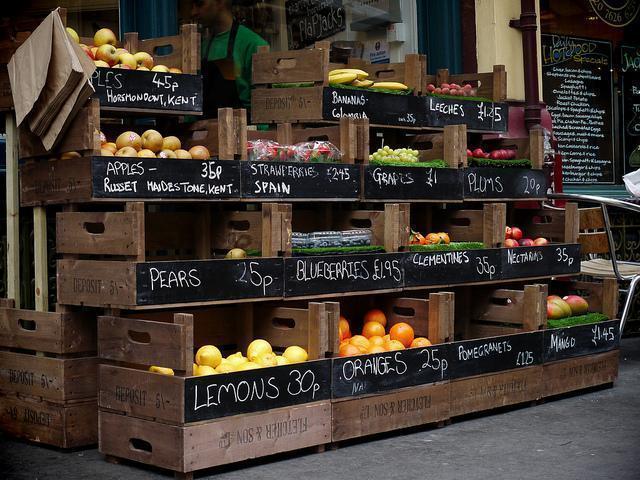What language must someone speak in order to understand what items are offered?
From the following set of four choices, select the accurate answer to respond to the question.
Options: English, spanish, french, italian. English. 